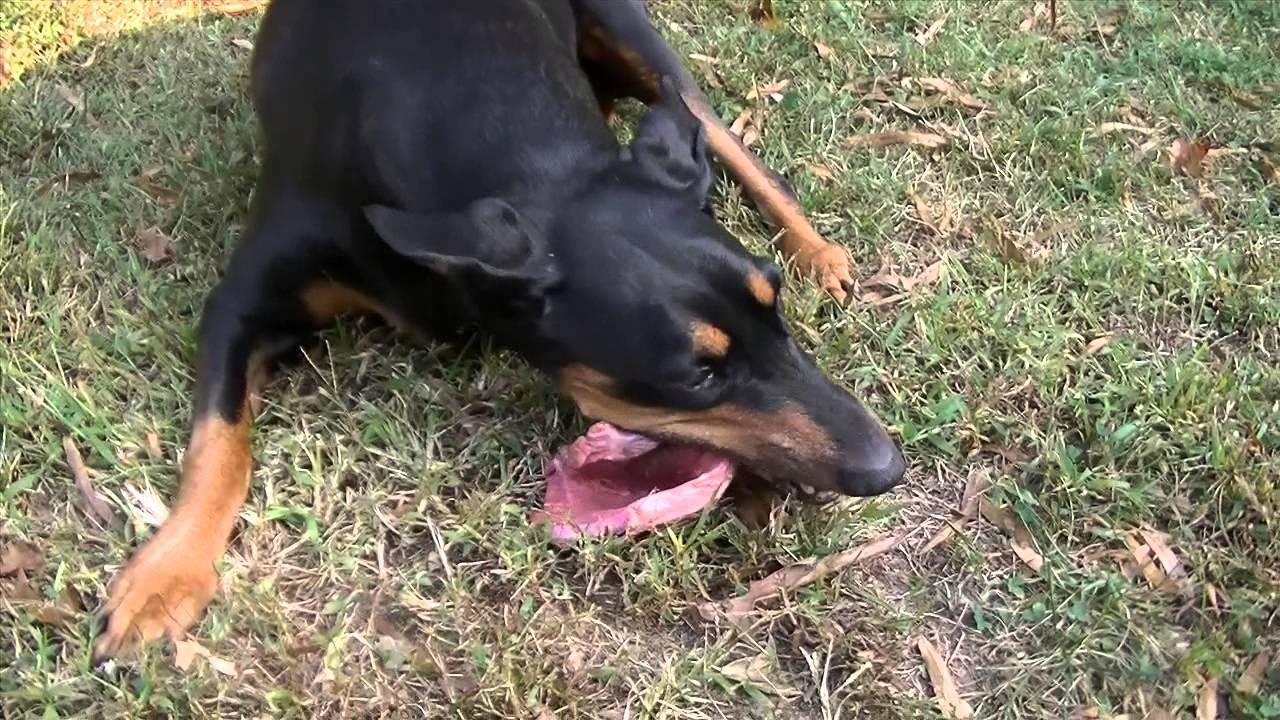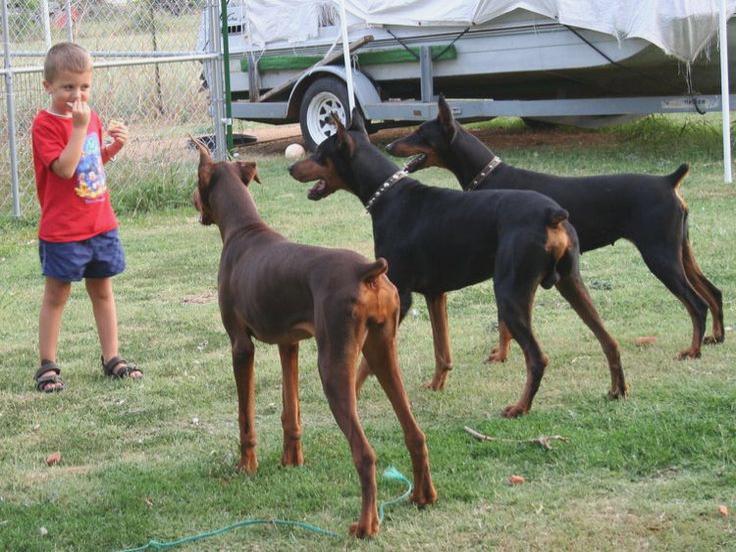The first image is the image on the left, the second image is the image on the right. Considering the images on both sides, is "The right image contains at least three dogs." valid? Answer yes or no. Yes. The first image is the image on the left, the second image is the image on the right. Considering the images on both sides, is "One dog is laying in the grass." valid? Answer yes or no. Yes. 